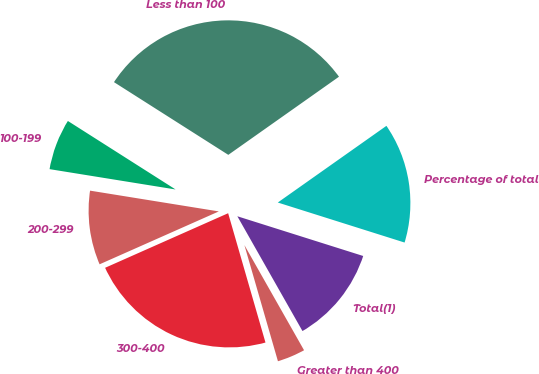Convert chart. <chart><loc_0><loc_0><loc_500><loc_500><pie_chart><fcel>Less than 100<fcel>100-199<fcel>200-299<fcel>300-400<fcel>Greater than 400<fcel>Total(1)<fcel>Percentage of total<nl><fcel>31.2%<fcel>6.47%<fcel>9.19%<fcel>22.83%<fcel>3.74%<fcel>11.92%<fcel>14.65%<nl></chart> 